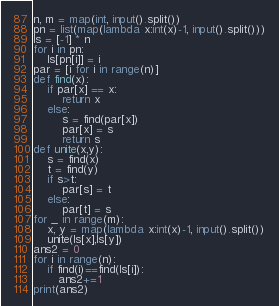Convert code to text. <code><loc_0><loc_0><loc_500><loc_500><_Python_>n, m = map(int, input().split())
pn = list(map(lambda x:int(x)-1, input().split()))
ls = [-1] * n
for i in pn:
    ls[pn[i]] = i
par = [i for i in range(n)]
def find(x):
    if par[x] == x:
        return x
    else:
        s = find(par[x])
        par[x] = s
        return s
def unite(x,y):
    s = find(x)
    t = find(y)
    if s>t:
        par[s] = t
    else:
        par[t] = s
for _ in range(m):
    x, y = map(lambda x:int(x)-1, input().split())
    unite(ls[x],ls[y])
ans2 = 0
for i in range(n):
    if find(i)==find(ls[i]):
       ans2+=1
print(ans2)</code> 